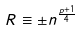Convert formula to latex. <formula><loc_0><loc_0><loc_500><loc_500>R \equiv \pm n ^ { \frac { p + 1 } { 4 } }</formula> 